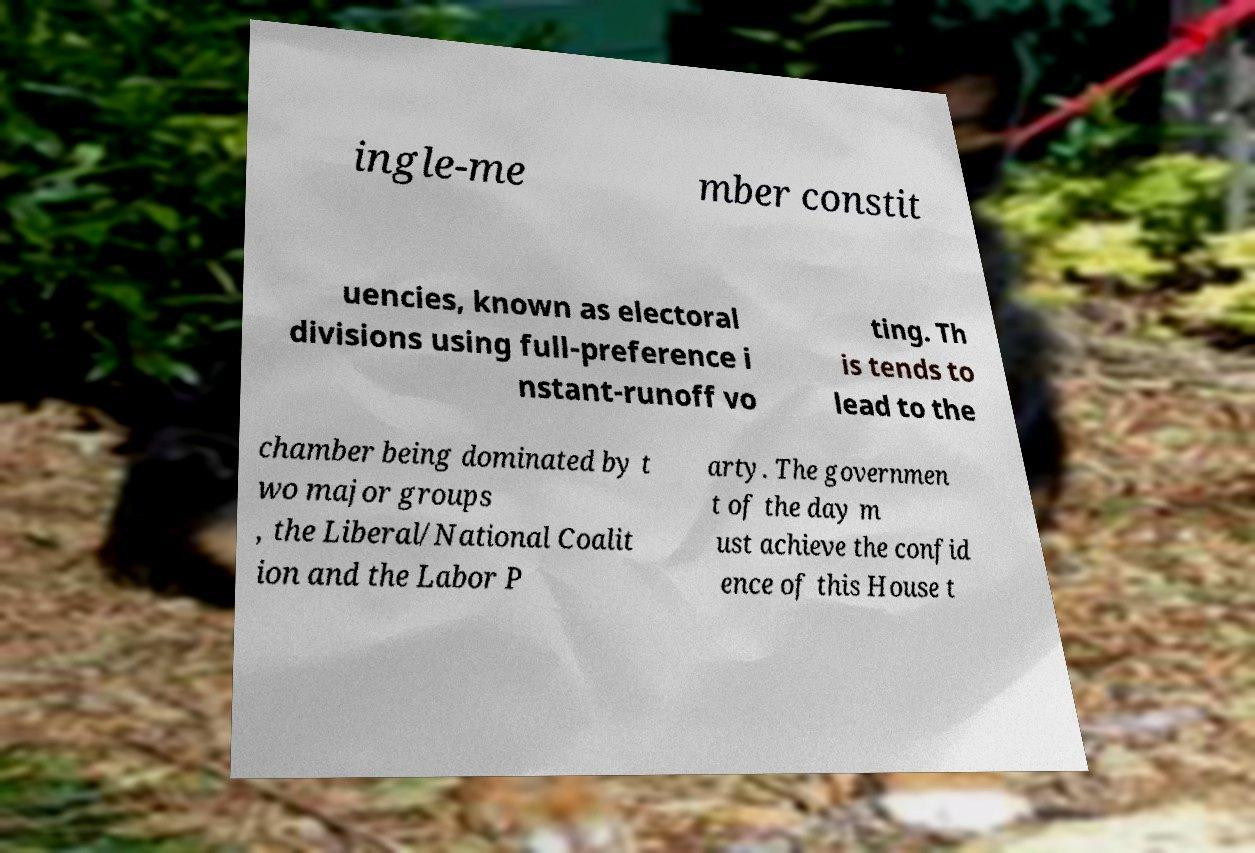Can you accurately transcribe the text from the provided image for me? ingle-me mber constit uencies, known as electoral divisions using full-preference i nstant-runoff vo ting. Th is tends to lead to the chamber being dominated by t wo major groups , the Liberal/National Coalit ion and the Labor P arty. The governmen t of the day m ust achieve the confid ence of this House t 